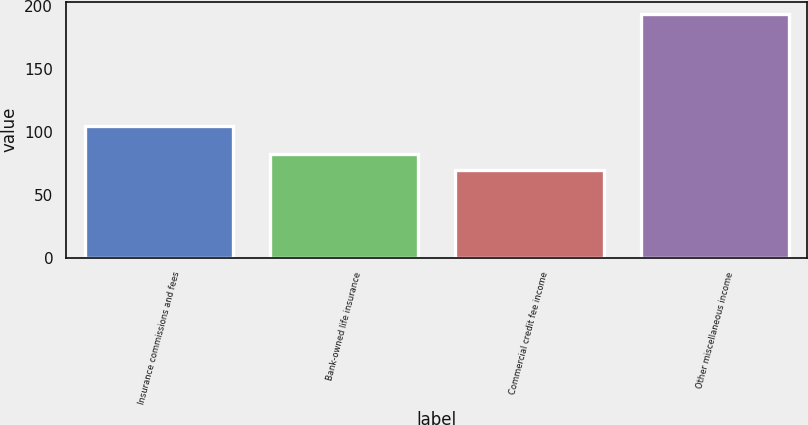<chart> <loc_0><loc_0><loc_500><loc_500><bar_chart><fcel>Insurance commissions and fees<fcel>Bank-owned life insurance<fcel>Commercial credit fee income<fcel>Other miscellaneous income<nl><fcel>105<fcel>82.4<fcel>70<fcel>194<nl></chart> 